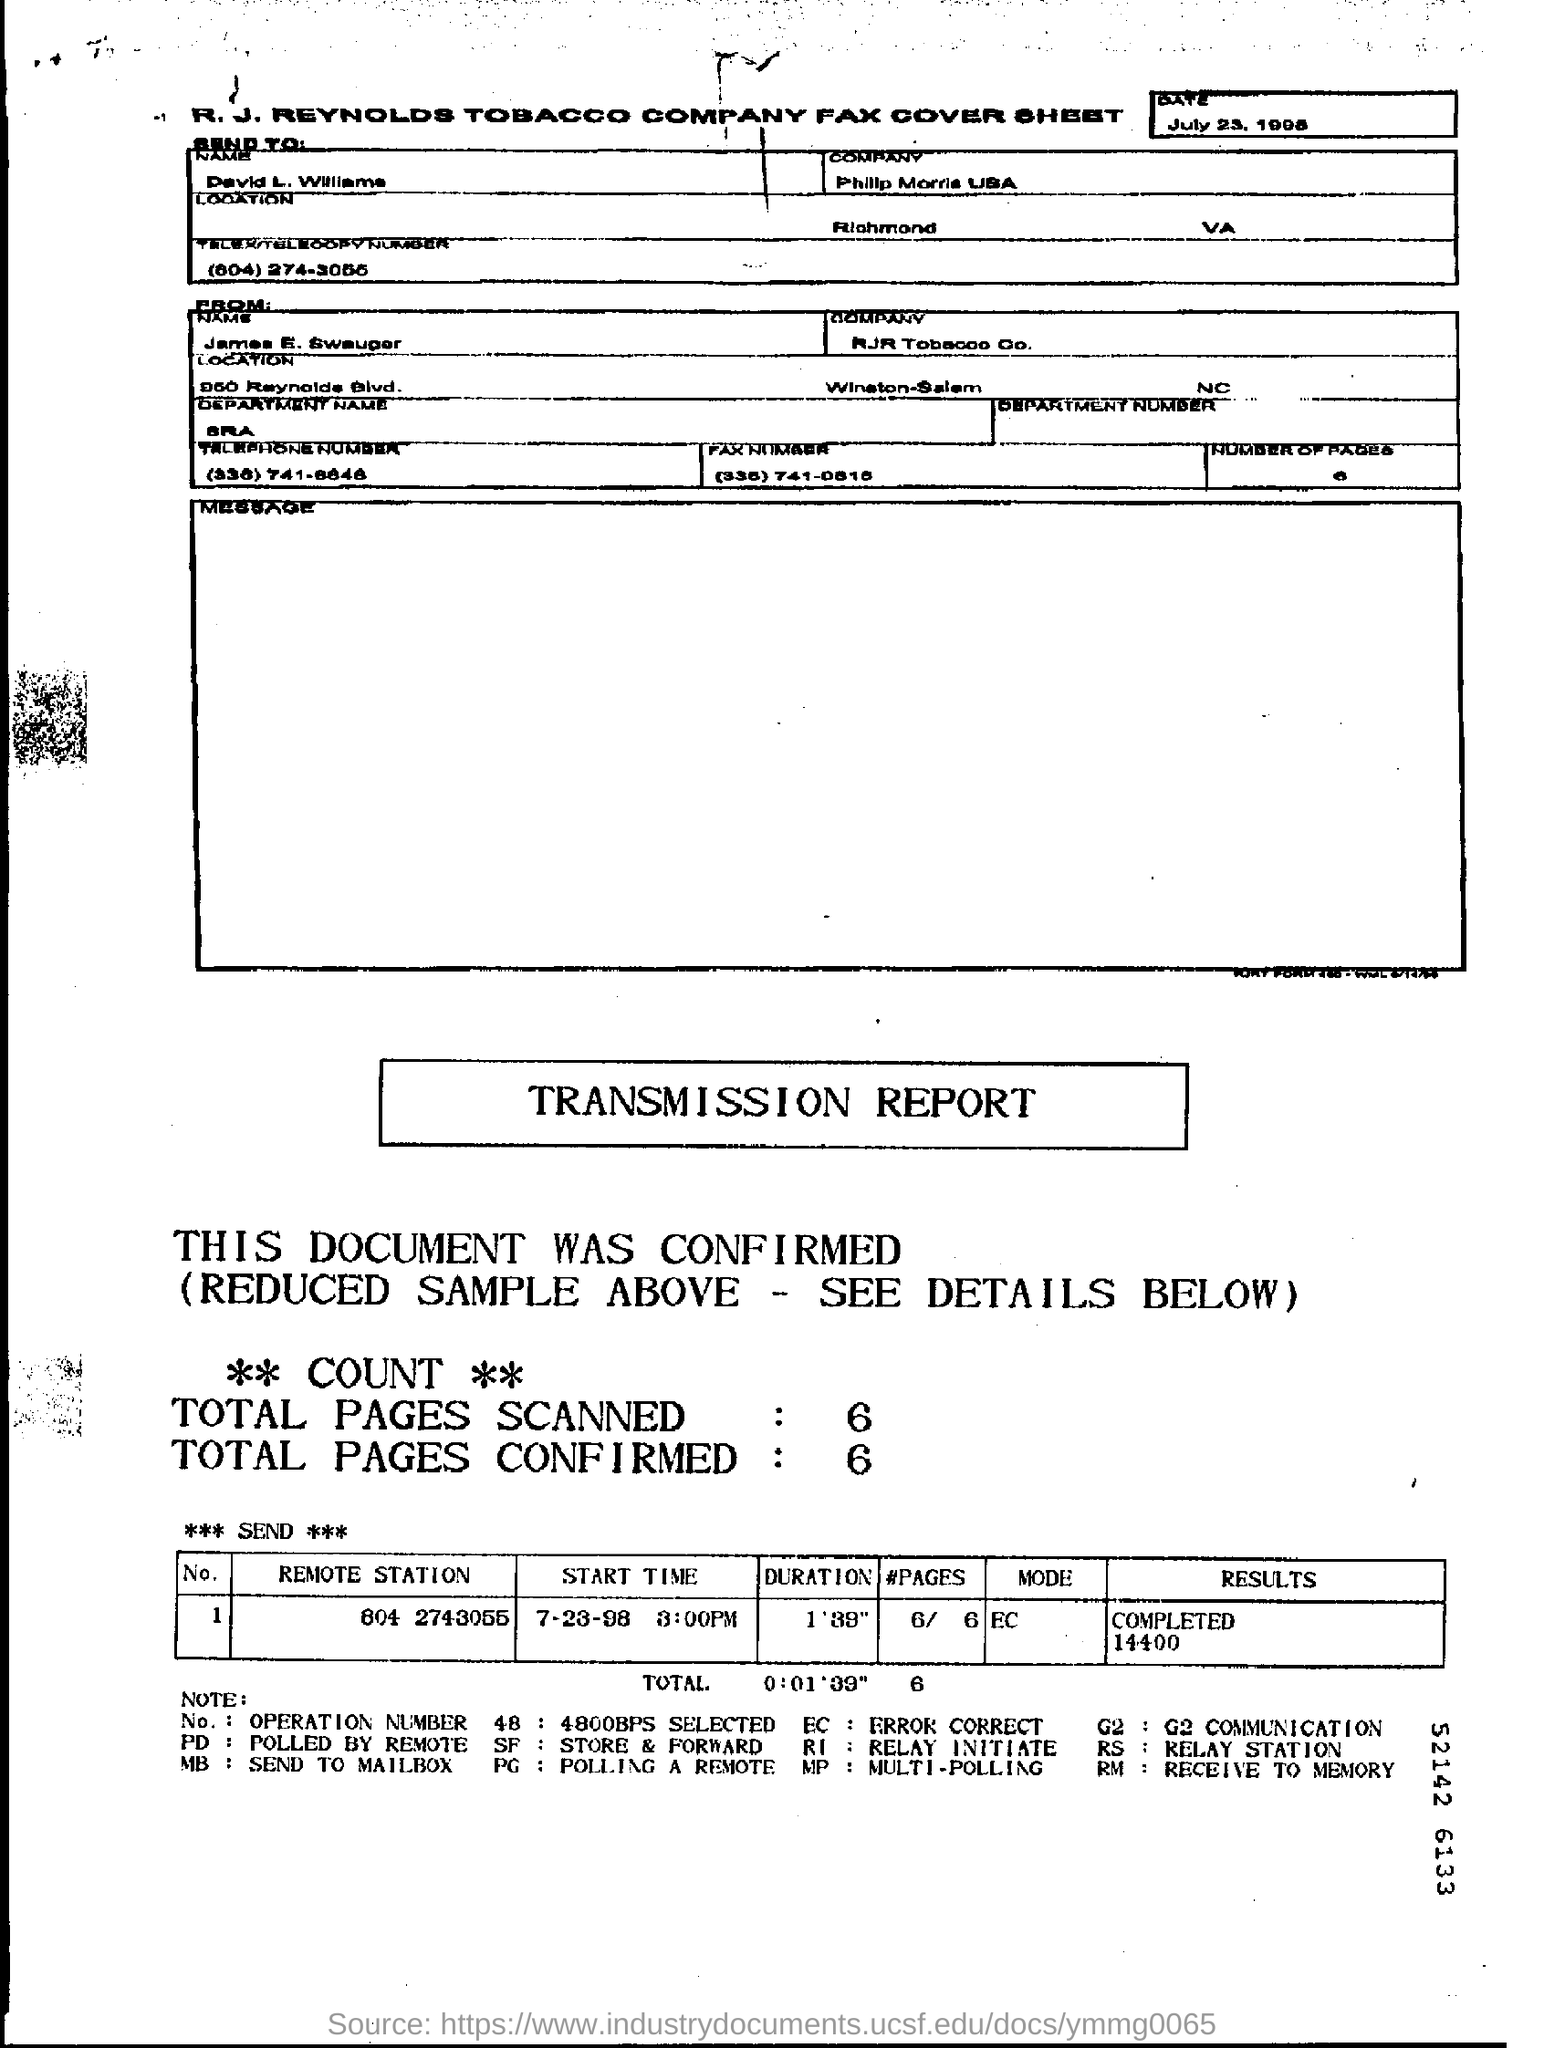Give some essential details in this illustration. The total number of pages scanned is 6. There are a total of 6 pages confirmed. 